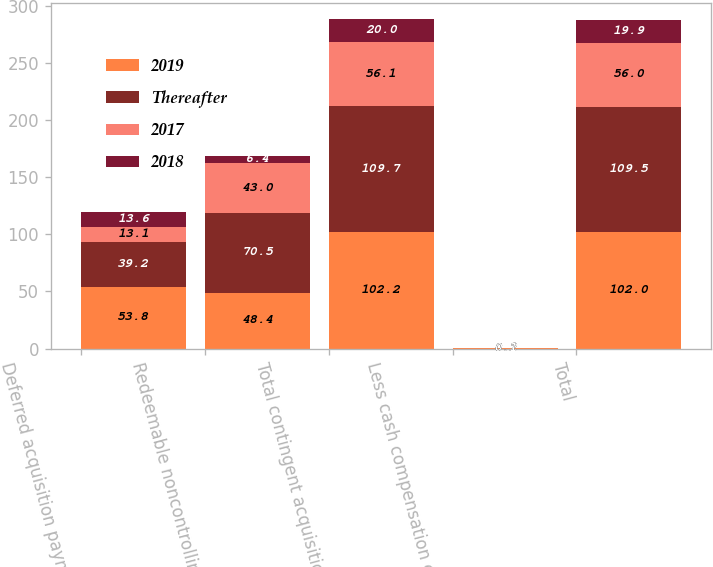Convert chart to OTSL. <chart><loc_0><loc_0><loc_500><loc_500><stacked_bar_chart><ecel><fcel>Deferred acquisition payments<fcel>Redeemable noncontrolling<fcel>Total contingent acquisition<fcel>Less cash compensation expense<fcel>Total<nl><fcel>2019<fcel>53.8<fcel>48.4<fcel>102.2<fcel>0.2<fcel>102<nl><fcel>Thereafter<fcel>39.2<fcel>70.5<fcel>109.7<fcel>0.2<fcel>109.5<nl><fcel>2017<fcel>13.1<fcel>43<fcel>56.1<fcel>0.1<fcel>56<nl><fcel>2018<fcel>13.6<fcel>6.4<fcel>20<fcel>0.1<fcel>19.9<nl></chart> 